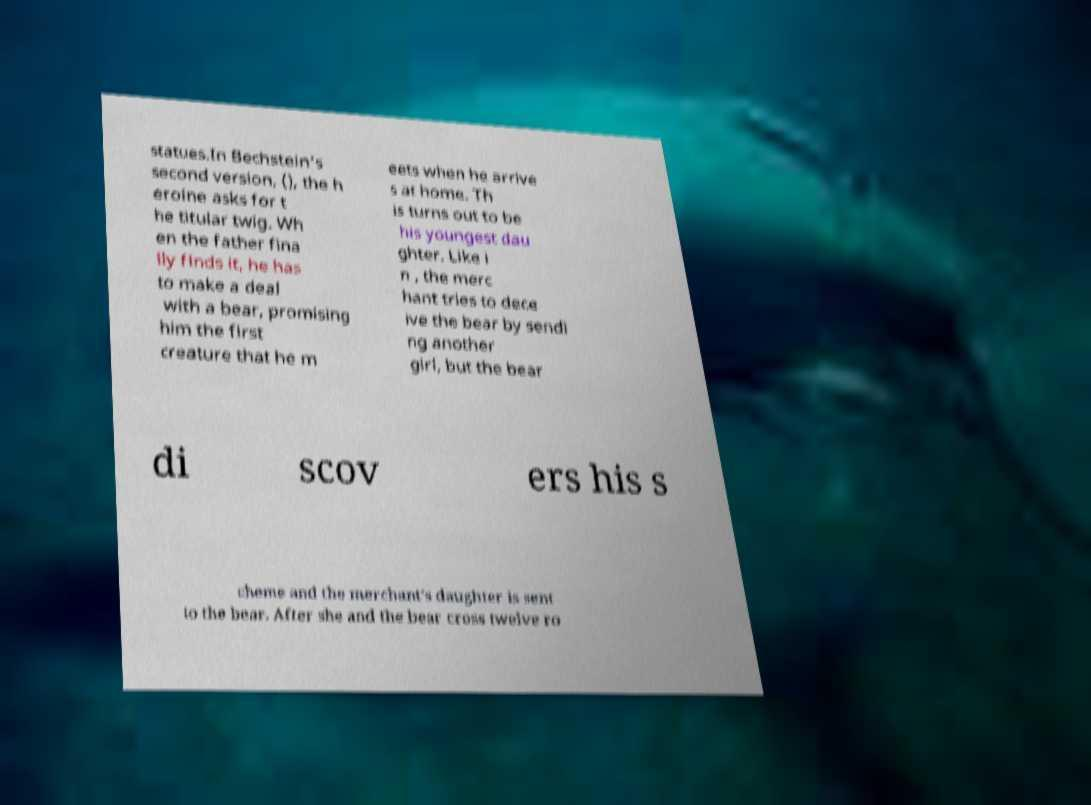Could you assist in decoding the text presented in this image and type it out clearly? statues.In Bechstein's second version, (), the h eroine asks for t he titular twig. Wh en the father fina lly finds it, he has to make a deal with a bear, promising him the first creature that he m eets when he arrive s at home. Th is turns out to be his youngest dau ghter. Like i n , the merc hant tries to dece ive the bear by sendi ng another girl, but the bear di scov ers his s cheme and the merchant's daughter is sent to the bear. After she and the bear cross twelve ro 